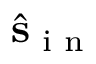Convert formula to latex. <formula><loc_0><loc_0><loc_500><loc_500>\hat { s } _ { i n }</formula> 